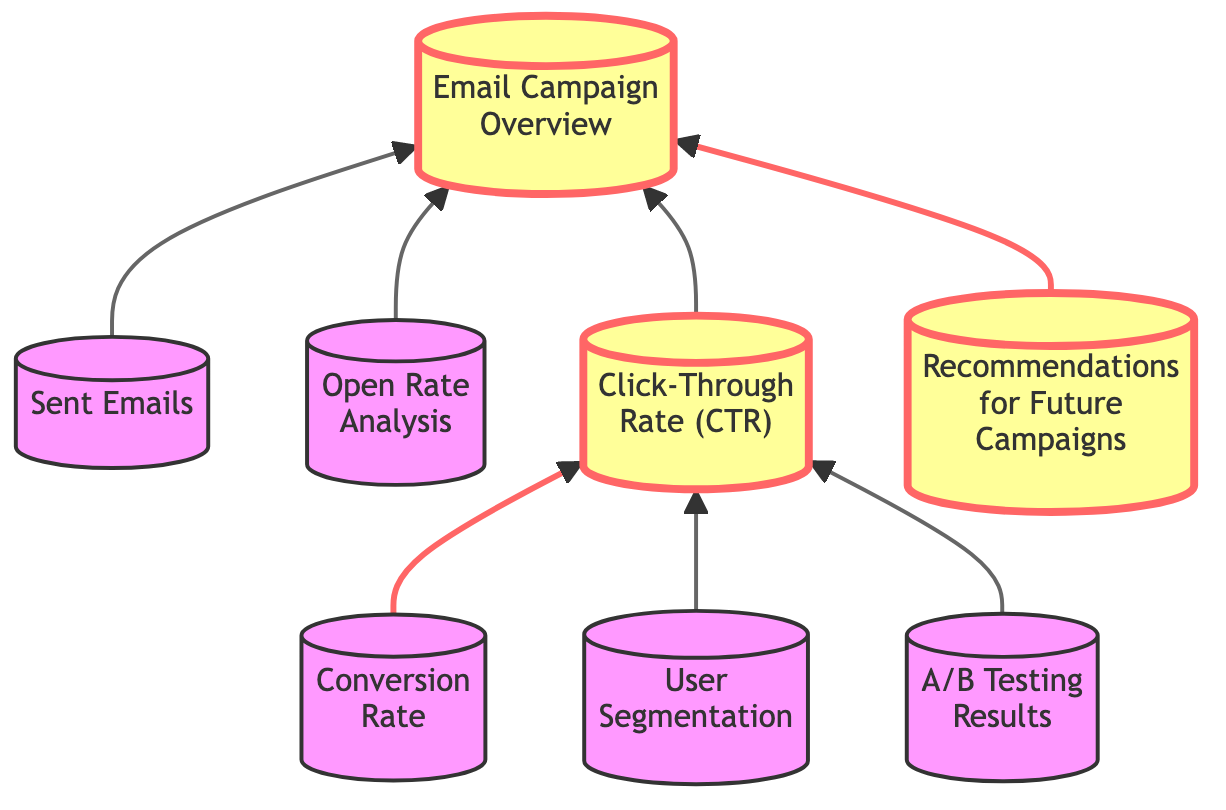What is the main highlight of the diagram? The main highlight of the diagram is the "Email Campaign Overview," which serves as a summary of the entire campaign. It is emphasized at the top of the flow chart.
Answer: Email Campaign Overview How many elements are explicitly mentioned in the diagram? The diagram includes a total of eight elements that detail various aspects of the email campaign performance review.
Answer: Eight Which two elements lead directly to the Click-Through Rate node? The two elements that lead directly to the "Click-Through Rate (CTR)" node are "Conversion Rate" and "User Segmentation," indicating that these analyses are critical for understanding CTR.
Answer: Conversion Rate, User Segmentation What insights are derived from the A/B Testing Results? The insights from the "A/B Testing Results" are included in the "Recommendations for Future Campaigns," signifying that insights gained influence future strategies.
Answer: Recommendations for Future Campaigns What role does the Sent Emails element play in the diagram? The "Sent Emails" element acts as a foundational element, linking to the "Email Campaign Overview," which summarizes the overall performance and strategy of the campaign.
Answer: Email Campaign Overview What does the link style indicate about the Open Rate Analysis and User Segmentation? The thicker link style for the "Open Rate Analysis" and "User Segmentation" indicates their significance in influencing the central node, "Email Campaign Overview," showing they are crucial metrics to monitor.
Answer: Significant metrics How does the Click-Through Rate relate to the Conversion Rate? The "Click-Through Rate (CTR)" feeds directly into the "Conversion Rate," indicating that the performance of CTR is essential for assessing the success of conversions post-click.
Answer: Direct relationship Which node's analysis contributes to multiple future strategies? The node that contributes to multiple future strategies is "Recommendations for Future Campaigns," collecting insights from various analyses indicated by the connecting nodes.
Answer: A comprehensive source 